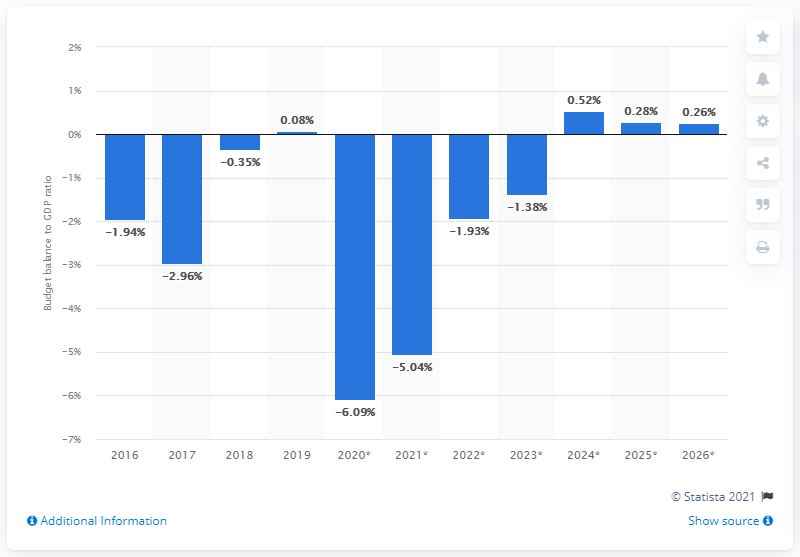Mention a couple of crucial points in this snapshot. In 2019, the state surplus of Portugal accounted for approximately 0.08% of the country's GDP. 